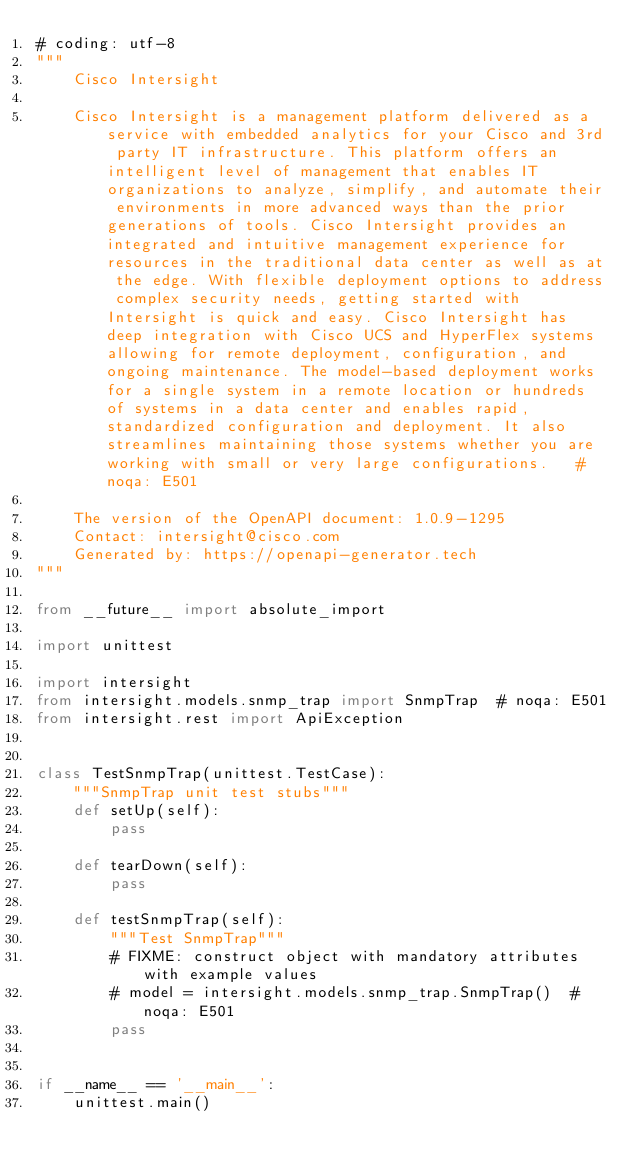Convert code to text. <code><loc_0><loc_0><loc_500><loc_500><_Python_># coding: utf-8
"""
    Cisco Intersight

    Cisco Intersight is a management platform delivered as a service with embedded analytics for your Cisco and 3rd party IT infrastructure. This platform offers an intelligent level of management that enables IT organizations to analyze, simplify, and automate their environments in more advanced ways than the prior generations of tools. Cisco Intersight provides an integrated and intuitive management experience for resources in the traditional data center as well as at the edge. With flexible deployment options to address complex security needs, getting started with Intersight is quick and easy. Cisco Intersight has deep integration with Cisco UCS and HyperFlex systems allowing for remote deployment, configuration, and ongoing maintenance. The model-based deployment works for a single system in a remote location or hundreds of systems in a data center and enables rapid, standardized configuration and deployment. It also streamlines maintaining those systems whether you are working with small or very large configurations.   # noqa: E501

    The version of the OpenAPI document: 1.0.9-1295
    Contact: intersight@cisco.com
    Generated by: https://openapi-generator.tech
"""

from __future__ import absolute_import

import unittest

import intersight
from intersight.models.snmp_trap import SnmpTrap  # noqa: E501
from intersight.rest import ApiException


class TestSnmpTrap(unittest.TestCase):
    """SnmpTrap unit test stubs"""
    def setUp(self):
        pass

    def tearDown(self):
        pass

    def testSnmpTrap(self):
        """Test SnmpTrap"""
        # FIXME: construct object with mandatory attributes with example values
        # model = intersight.models.snmp_trap.SnmpTrap()  # noqa: E501
        pass


if __name__ == '__main__':
    unittest.main()
</code> 